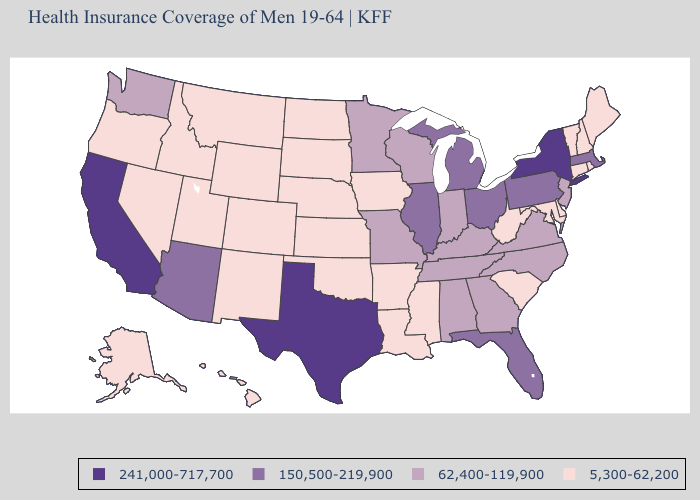Does Alaska have the highest value in the USA?
Be succinct. No. What is the value of Hawaii?
Quick response, please. 5,300-62,200. What is the lowest value in the West?
Be succinct. 5,300-62,200. How many symbols are there in the legend?
Be succinct. 4. Does Virginia have the highest value in the USA?
Short answer required. No. Does Delaware have the same value as Tennessee?
Answer briefly. No. How many symbols are there in the legend?
Keep it brief. 4. What is the value of California?
Give a very brief answer. 241,000-717,700. Among the states that border Idaho , does Washington have the highest value?
Write a very short answer. Yes. Which states hav the highest value in the West?
Answer briefly. California. Name the states that have a value in the range 5,300-62,200?
Quick response, please. Alaska, Arkansas, Colorado, Connecticut, Delaware, Hawaii, Idaho, Iowa, Kansas, Louisiana, Maine, Maryland, Mississippi, Montana, Nebraska, Nevada, New Hampshire, New Mexico, North Dakota, Oklahoma, Oregon, Rhode Island, South Carolina, South Dakota, Utah, Vermont, West Virginia, Wyoming. Does South Dakota have the highest value in the MidWest?
Write a very short answer. No. Which states have the lowest value in the USA?
Concise answer only. Alaska, Arkansas, Colorado, Connecticut, Delaware, Hawaii, Idaho, Iowa, Kansas, Louisiana, Maine, Maryland, Mississippi, Montana, Nebraska, Nevada, New Hampshire, New Mexico, North Dakota, Oklahoma, Oregon, Rhode Island, South Carolina, South Dakota, Utah, Vermont, West Virginia, Wyoming. What is the highest value in states that border North Dakota?
Write a very short answer. 62,400-119,900. Does the first symbol in the legend represent the smallest category?
Give a very brief answer. No. 